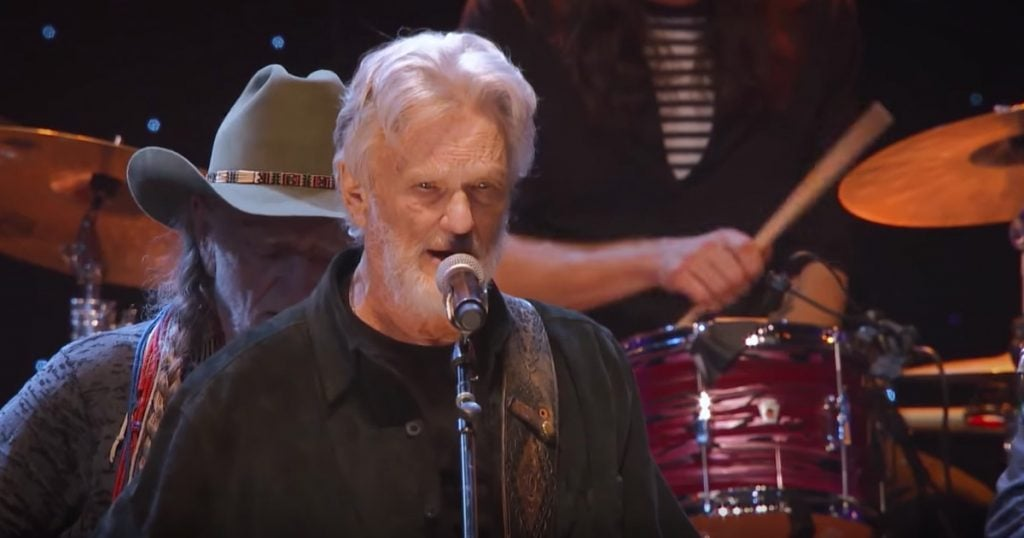Imagine if the musicians in the image were to perform in a completely different genre. What would the changes look like? If the musicians were to perform in a completely different genre, such as electronic dance music (EDM), significant changes would be notable. The attire might shift to more modern, edgy outfits with vibrant colors and futuristic designs. Instruments might include synthesizers, electronic drum kits, and DJ turntables instead of traditional guitars and drums. The stage setup would likely incorporate dynamic light shows, visual effects, and potentially even screens displaying graphics to match the high-energy, visually immersive environment typical of EDM performances. What creative, imaginary scenario could add a unique twist to this musical performance? Imagine this performance taking place on a space station orbiting the Earth! The musicians could be dressed in vintage astronaut suits adapted to allow them to play their instruments. The audience would be fellow space travelers floating in zero-g and watching through panoramic windows with Earth visible in the background. Holographic visuals sync with the music, creating an otherworldly experience that blends traditional music with a futuristic setting, making for a once-in-a-lifetime concert beyond the stars. 